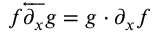<formula> <loc_0><loc_0><loc_500><loc_500>f { \overleftarrow { \partial _ { x } } } g = g \cdot \partial _ { x } f</formula> 